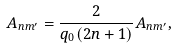Convert formula to latex. <formula><loc_0><loc_0><loc_500><loc_500>A _ { n m ^ { \prime } } = \frac { 2 } { q _ { 0 } ( 2 n + 1 ) } A _ { n m ^ { \prime } } ,</formula> 